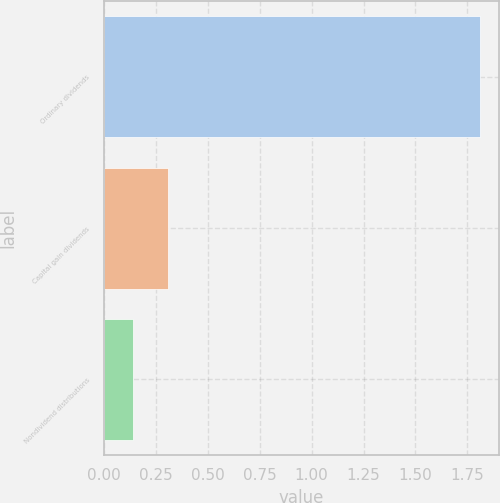<chart> <loc_0><loc_0><loc_500><loc_500><bar_chart><fcel>Ordinary dividends<fcel>Capital gain dividends<fcel>Nondividend distributions<nl><fcel>1.81<fcel>0.31<fcel>0.14<nl></chart> 